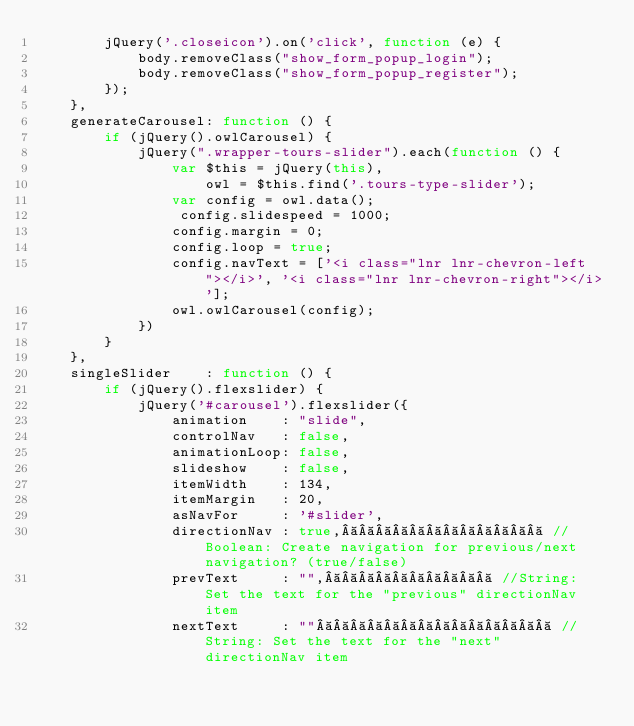<code> <loc_0><loc_0><loc_500><loc_500><_JavaScript_>		jQuery('.closeicon').on('click', function (e) {
			body.removeClass("show_form_popup_login");
			body.removeClass("show_form_popup_register");
		});
	},
	generateCarousel: function () {
		if (jQuery().owlCarousel) {
			jQuery(".wrapper-tours-slider").each(function () {
				var $this = jQuery(this),
					owl = $this.find('.tours-type-slider');
				var config = owl.data();
				 config.slidespeed = 1000;
				config.margin = 0;
				config.loop = true;
				config.navText = ['<i class="lnr lnr-chevron-left"></i>', '<i class="lnr lnr-chevron-right"></i>'];
				owl.owlCarousel(config);
			})
		}
	},
	singleSlider    : function () {
		if (jQuery().flexslider) {
			jQuery('#carousel').flexslider({
				animation    : "slide",
				controlNav   : false,
				animationLoop: false,
				slideshow    : false,
				itemWidth    : 134,
				itemMargin   : 20,
				asNavFor     : '#slider',
				directionNav : true,             //Boolean: Create navigation for previous/next navigation? (true/false)
				prevText     : "",           //String: Set the text for the "previous" directionNav item
				nextText     : ""               //String: Set the text for the "next" directionNav item</code> 